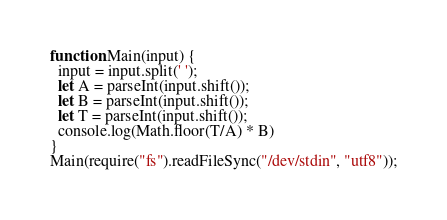<code> <loc_0><loc_0><loc_500><loc_500><_JavaScript_>
function Main(input) {
  input = input.split(' ');
  let A = parseInt(input.shift());
  let B = parseInt(input.shift());
  let T = parseInt(input.shift());
  console.log(Math.floor(T/A) * B)
}
Main(require("fs").readFileSync("/dev/stdin", "utf8"));</code> 